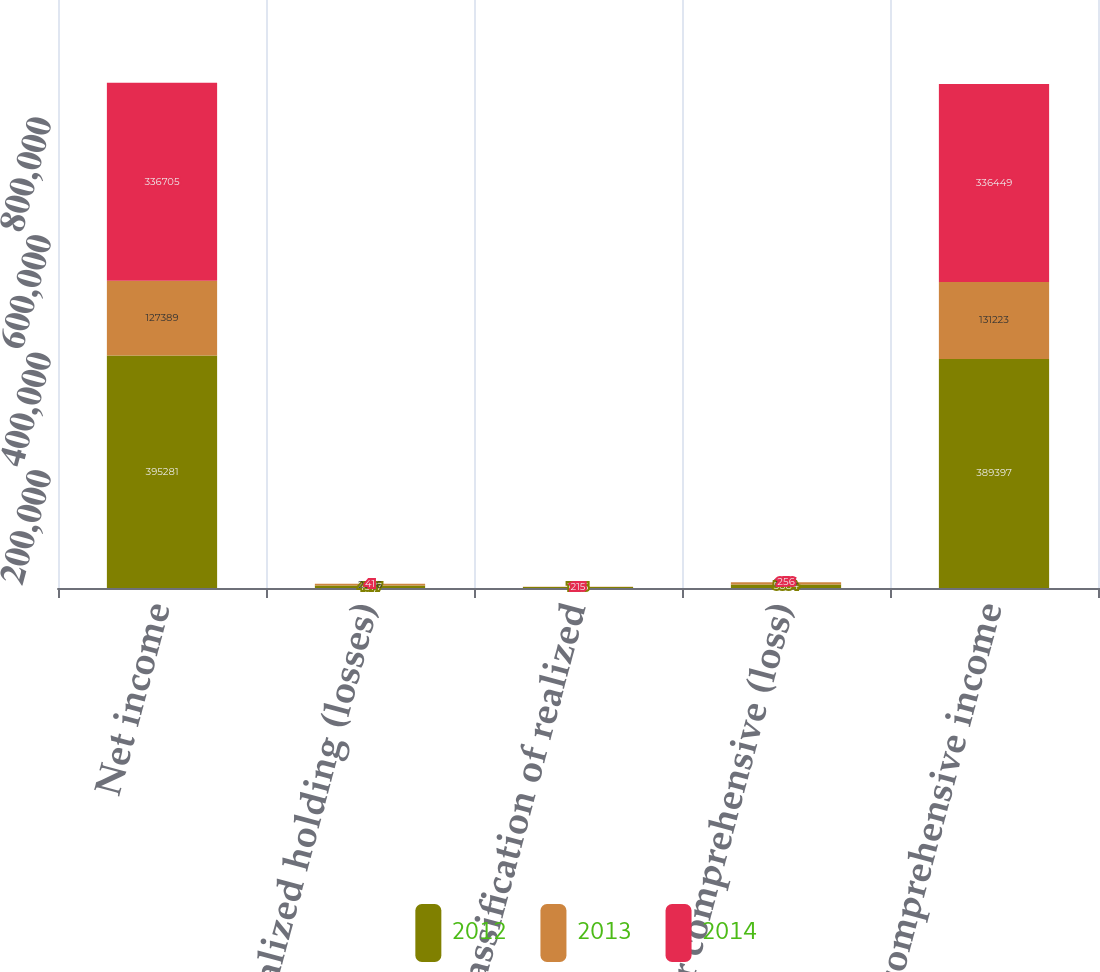<chart> <loc_0><loc_0><loc_500><loc_500><stacked_bar_chart><ecel><fcel>Net income<fcel>Unrealized holding (losses)<fcel>Reclassification of realized<fcel>Other comprehensive (loss)<fcel>Total comprehensive income<nl><fcel>2012<fcel>395281<fcel>4377<fcel>1595<fcel>5884<fcel>389397<nl><fcel>2013<fcel>127389<fcel>2686<fcel>343<fcel>3834<fcel>131223<nl><fcel>2014<fcel>336705<fcel>41<fcel>215<fcel>256<fcel>336449<nl></chart> 